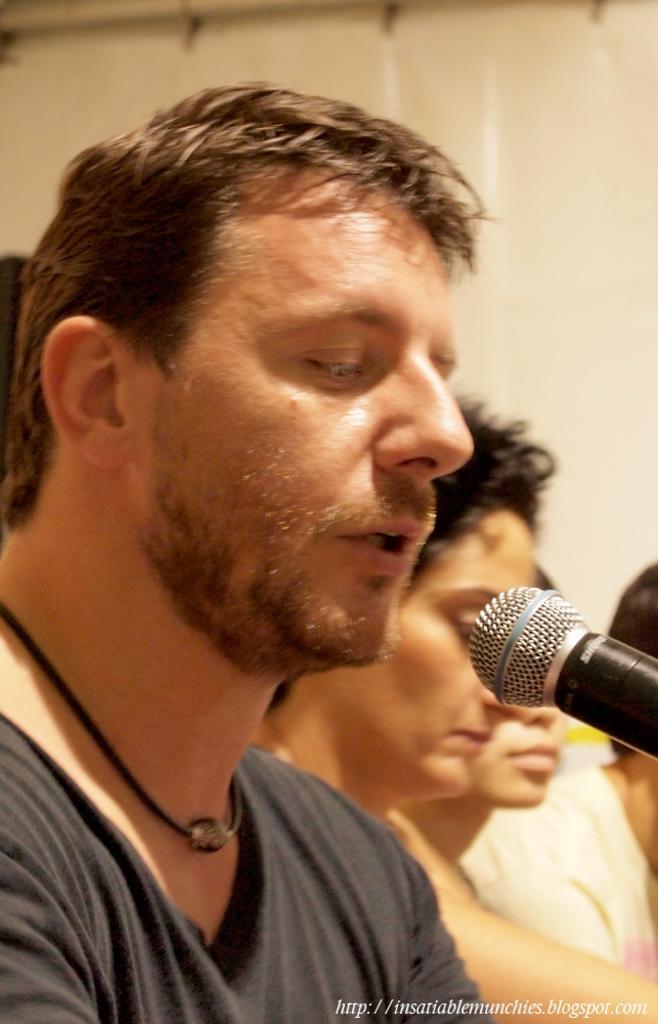Describe this image in one or two sentences. In this picture I can see there is a man sitting and he is speaking, there is a microphone in front of him and there are few other people sitting beside him and there is a wall in the backdrop. 